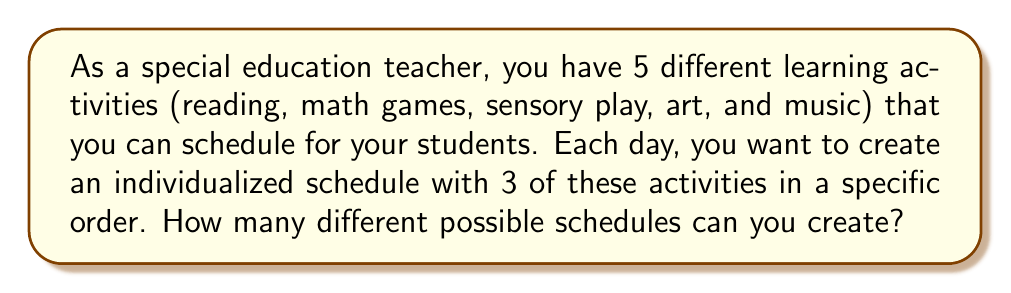Can you solve this math problem? Let's approach this step-by-step:

1) This is a permutation problem because the order of activities matters in the schedule.

2) We are selecting 3 activities out of 5, and the order is important.

3) The formula for permutations is:

   $$P(n,r) = \frac{n!}{(n-r)!}$$

   Where $n$ is the total number of items to choose from, and $r$ is the number of items being chosen.

4) In this case, $n = 5$ (total activities) and $r = 3$ (activities per schedule).

5) Plugging these values into the formula:

   $$P(5,3) = \frac{5!}{(5-3)!} = \frac{5!}{2!}$$

6) Expanding this:
   
   $$\frac{5 \times 4 \times 3 \times 2!}{2!}$$

7) The 2! cancels out in the numerator and denominator:

   $$5 \times 4 \times 3 = 60$$

Therefore, there are 60 different possible schedules that can be created.
Answer: 60 